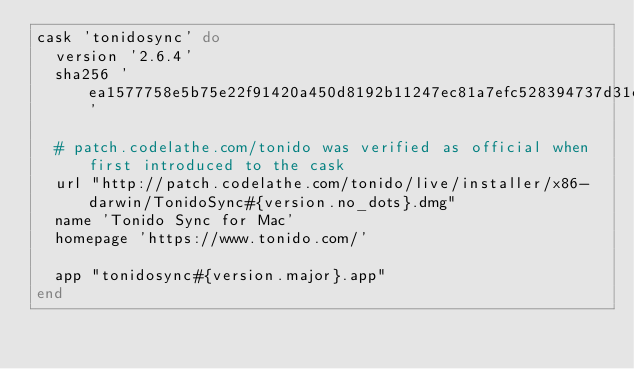<code> <loc_0><loc_0><loc_500><loc_500><_Ruby_>cask 'tonidosync' do
  version '2.6.4'
  sha256 'ea1577758e5b75e22f91420a450d8192b11247ec81a7efc528394737d31e9c11'

  # patch.codelathe.com/tonido was verified as official when first introduced to the cask
  url "http://patch.codelathe.com/tonido/live/installer/x86-darwin/TonidoSync#{version.no_dots}.dmg"
  name 'Tonido Sync for Mac'
  homepage 'https://www.tonido.com/'

  app "tonidosync#{version.major}.app"
end
</code> 